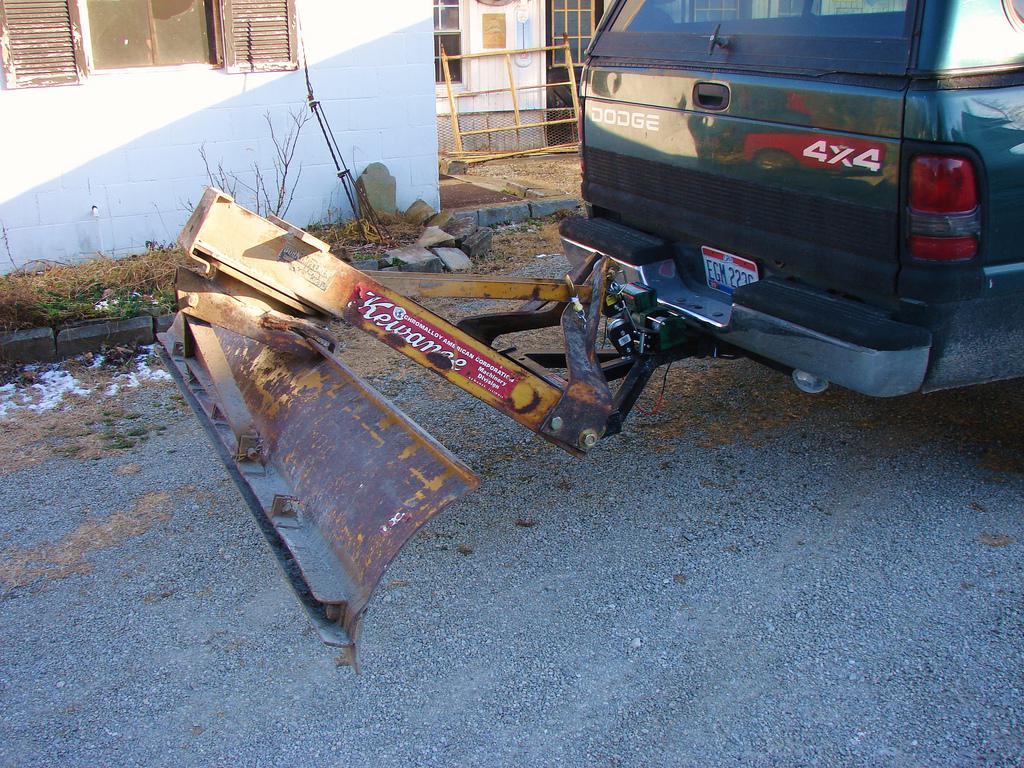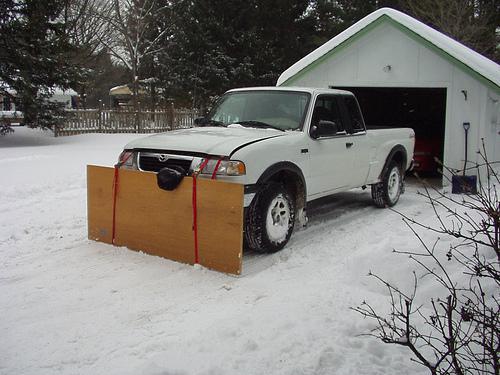The first image is the image on the left, the second image is the image on the right. For the images displayed, is the sentence "At least one tire is visible in one of the images." factually correct? Answer yes or no. Yes. The first image is the image on the left, the second image is the image on the right. Assess this claim about the two images: "An image shows an attached snow plow on a snow-covered ground.". Correct or not? Answer yes or no. Yes. 